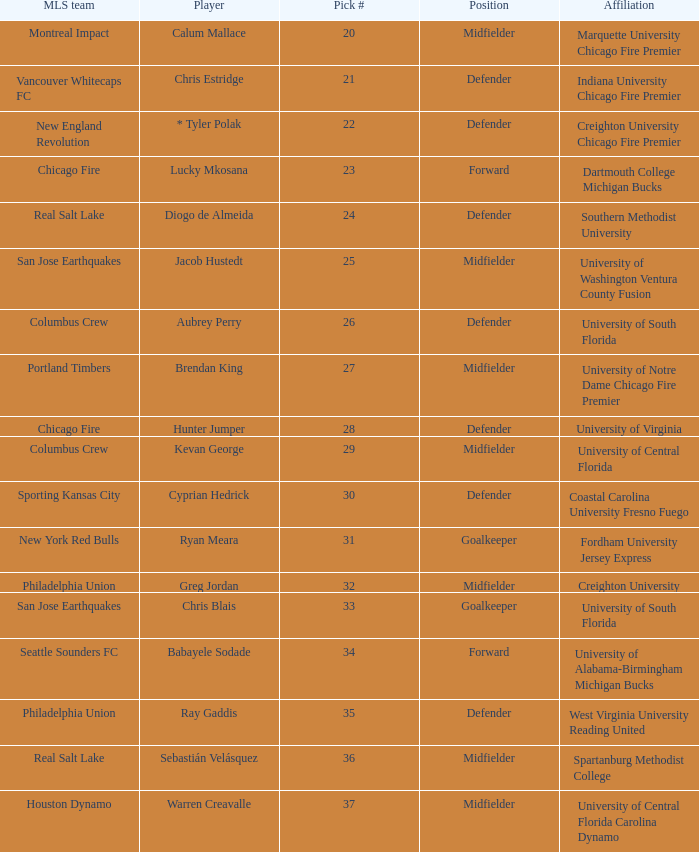What university was Kevan George affiliated with? University of Central Florida. 